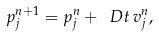Convert formula to latex. <formula><loc_0><loc_0><loc_500><loc_500>p ^ { n + 1 } _ { j } = p ^ { n } _ { j } + \ D t \, v _ { j } ^ { n } ,</formula> 